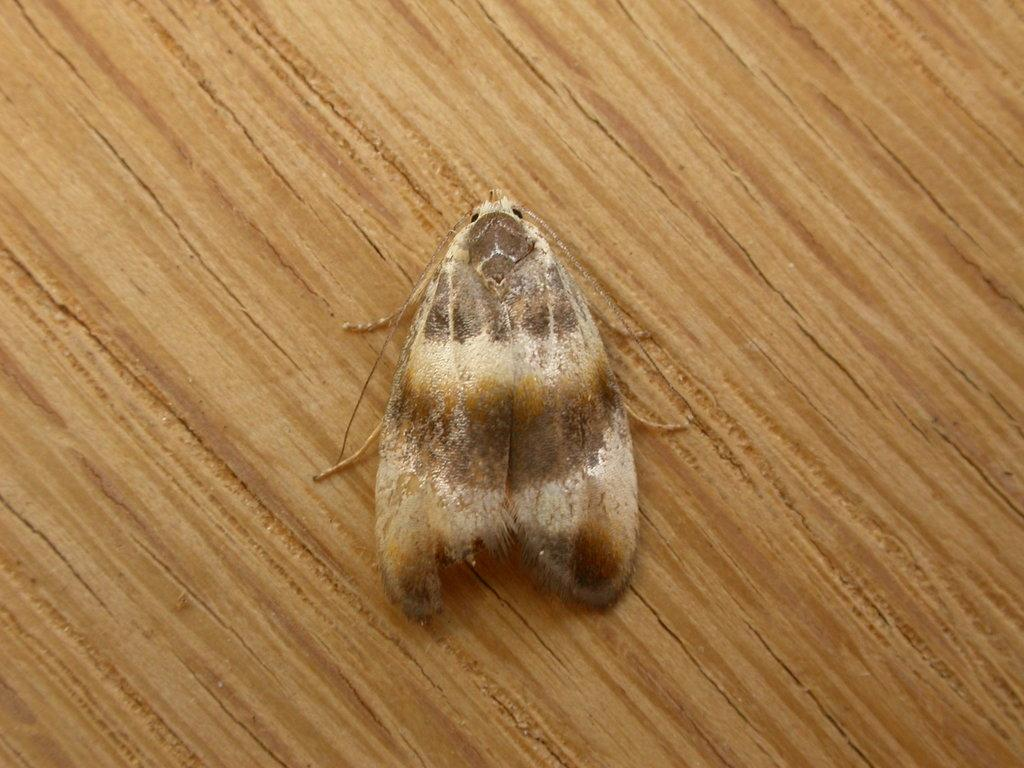What is present on the wooden surface in the image? There is an insect on the wooden surface in the image. Can you describe the wooden surface in the image? The wooden surface is the background on which the insect is present. What type of card is the worm holding in the image? There is no worm or card present in the image; it only features an insect on a wooden surface. 